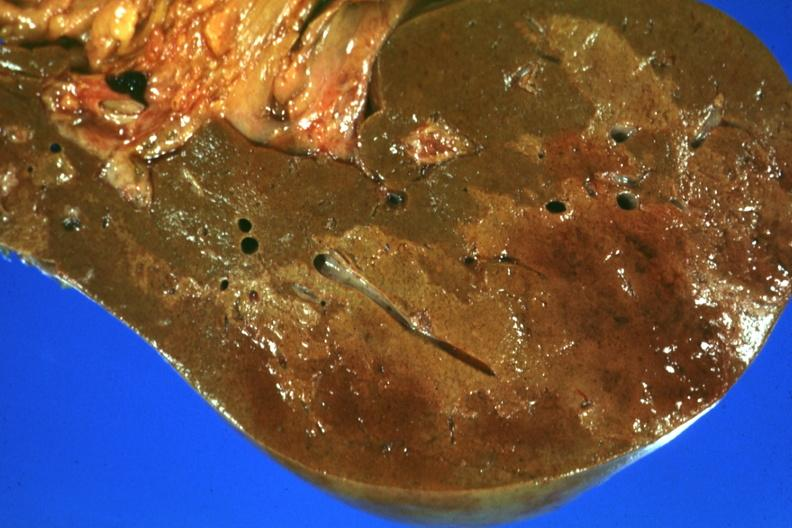what well seen?
Answer the question using a single word or phrase. Frontal section with large patch of central infarction 